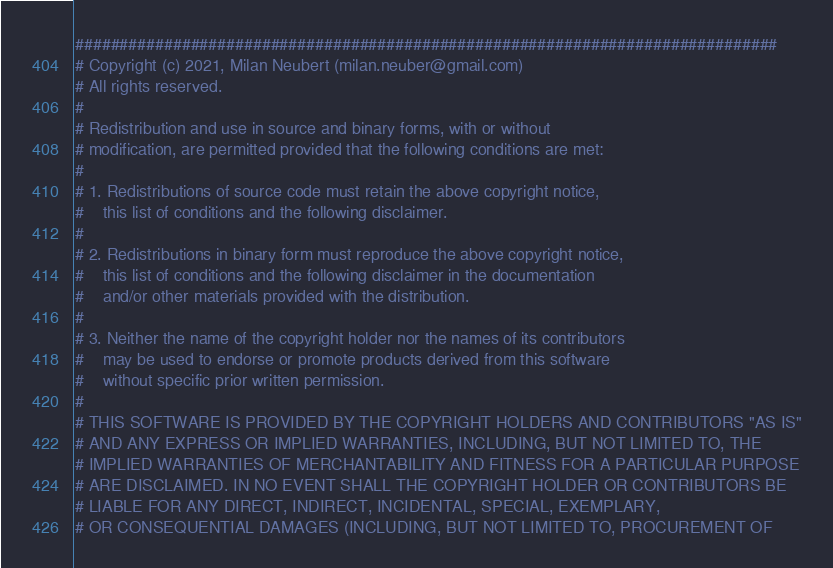<code> <loc_0><loc_0><loc_500><loc_500><_Python_>###############################################################################
# Copyright (c) 2021, Milan Neubert (milan.neuber@gmail.com)
# All rights reserved.
#
# Redistribution and use in source and binary forms, with or without
# modification, are permitted provided that the following conditions are met:
#
# 1. Redistributions of source code must retain the above copyright notice,
#    this list of conditions and the following disclaimer.
#
# 2. Redistributions in binary form must reproduce the above copyright notice,
#    this list of conditions and the following disclaimer in the documentation
#    and/or other materials provided with the distribution.
#
# 3. Neither the name of the copyright holder nor the names of its contributors
#    may be used to endorse or promote products derived from this software
#    without specific prior written permission.
#
# THIS SOFTWARE IS PROVIDED BY THE COPYRIGHT HOLDERS AND CONTRIBUTORS "AS IS"
# AND ANY EXPRESS OR IMPLIED WARRANTIES, INCLUDING, BUT NOT LIMITED TO, THE
# IMPLIED WARRANTIES OF MERCHANTABILITY AND FITNESS FOR A PARTICULAR PURPOSE
# ARE DISCLAIMED. IN NO EVENT SHALL THE COPYRIGHT HOLDER OR CONTRIBUTORS BE
# LIABLE FOR ANY DIRECT, INDIRECT, INCIDENTAL, SPECIAL, EXEMPLARY,
# OR CONSEQUENTIAL DAMAGES (INCLUDING, BUT NOT LIMITED TO, PROCUREMENT OF</code> 